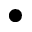Convert formula to latex. <formula><loc_0><loc_0><loc_500><loc_500>\bullet</formula> 